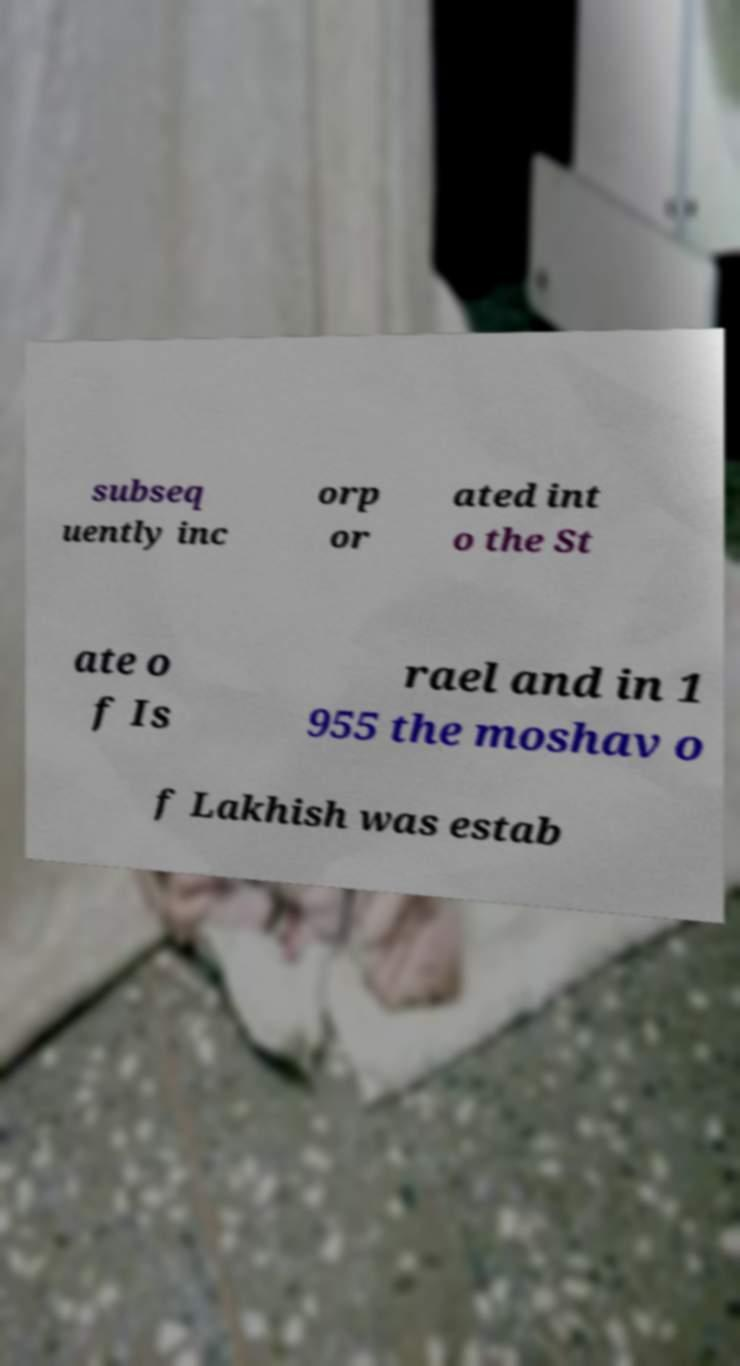There's text embedded in this image that I need extracted. Can you transcribe it verbatim? subseq uently inc orp or ated int o the St ate o f Is rael and in 1 955 the moshav o f Lakhish was estab 